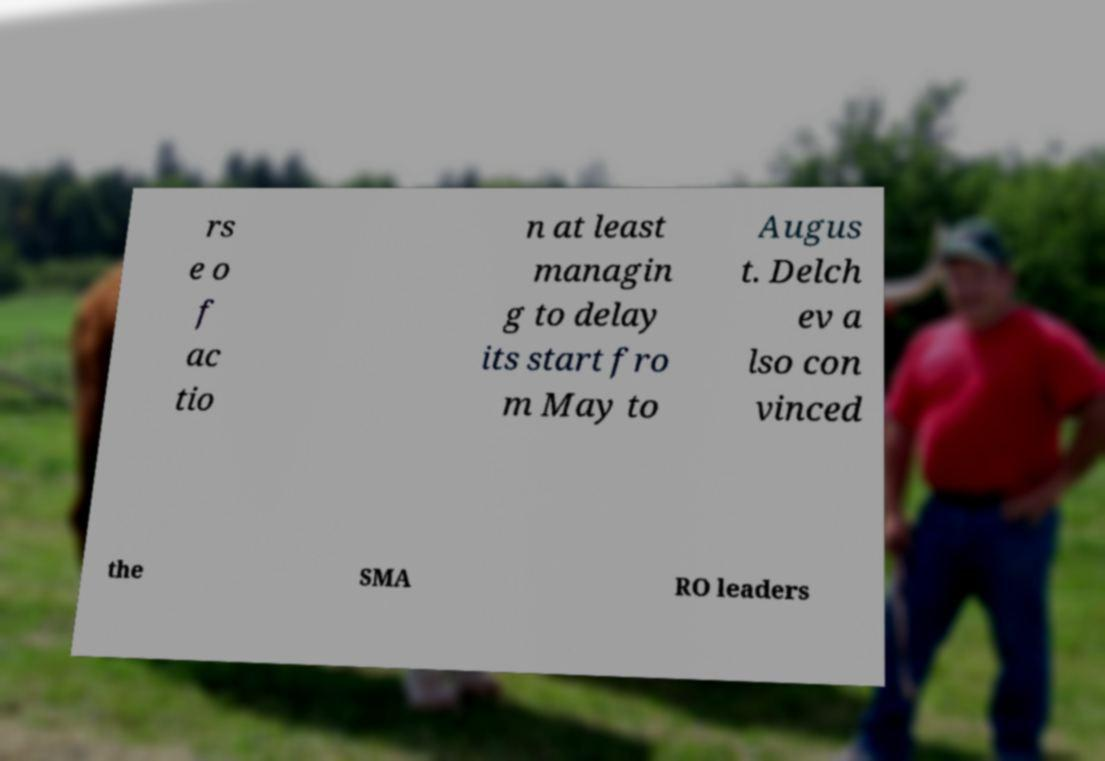For documentation purposes, I need the text within this image transcribed. Could you provide that? rs e o f ac tio n at least managin g to delay its start fro m May to Augus t. Delch ev a lso con vinced the SMA RO leaders 